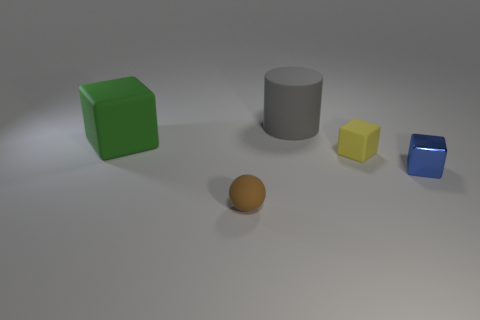Add 2 large metal cylinders. How many objects exist? 7 Subtract all cylinders. How many objects are left? 4 Add 1 cylinders. How many cylinders are left? 2 Add 5 big purple metallic cylinders. How many big purple metallic cylinders exist? 5 Subtract 1 blue blocks. How many objects are left? 4 Subtract all tiny rubber balls. Subtract all green things. How many objects are left? 3 